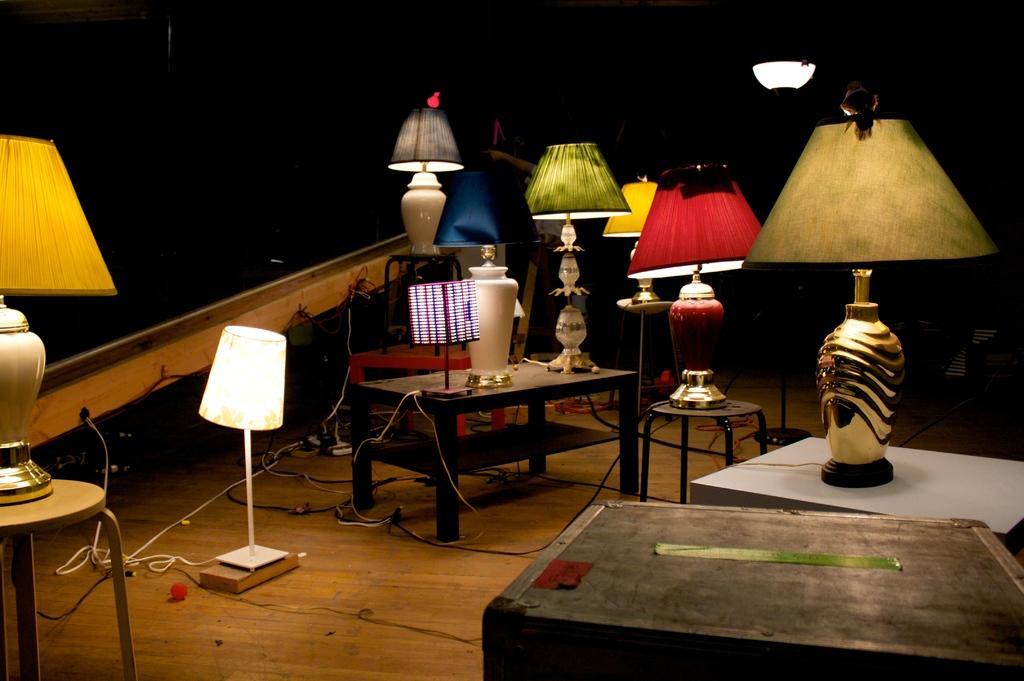Please provide a concise description of this image. In this image I can see tables, lamps, wires on the floor. The background is dark in color. This image is taken may be during night in a room. 